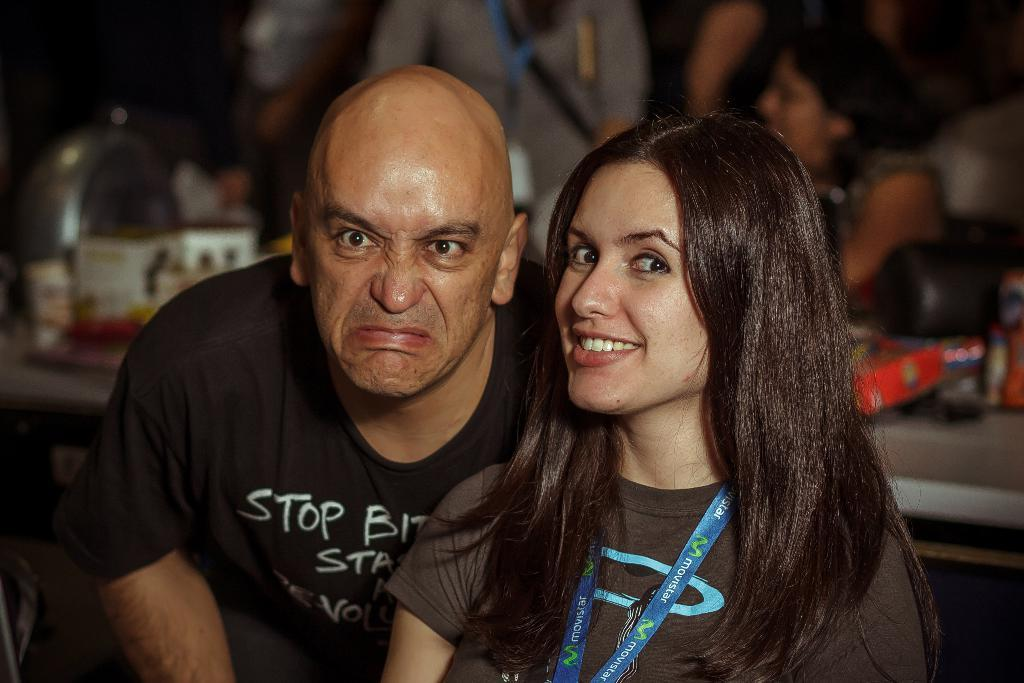How many people are present in the image? There are two people, a woman and a man, present in the image. What are the woman and the man doing in the image? The woman and the man are watching something in the image. What is the facial expression of the woman in the image? The woman is smiling in the image. Can you describe the background of the image? The background of the image is blurred, and there are people and objects visible in the background. What type of marble is being used to roll in the image? There is no marble or rolling activity present in the image. What view can be seen from the window in the image? There is no window or view visible in the image. 